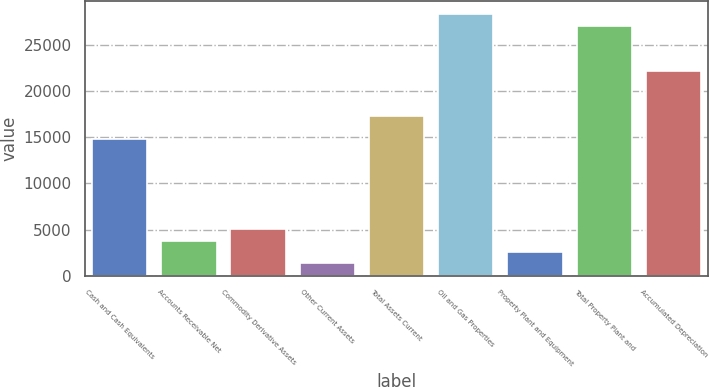Convert chart. <chart><loc_0><loc_0><loc_500><loc_500><bar_chart><fcel>Cash and Cash Equivalents<fcel>Accounts Receivable Net<fcel>Commodity Derivative Assets<fcel>Other Current Assets<fcel>Total Assets Current<fcel>Oil and Gas Properties<fcel>Property Plant and Equipment<fcel>Total Property Plant and<fcel>Accumulated Depreciation<nl><fcel>14838.8<fcel>3792.2<fcel>5019.6<fcel>1337.4<fcel>17293.6<fcel>28340.2<fcel>2564.8<fcel>27112.8<fcel>22203.2<nl></chart> 